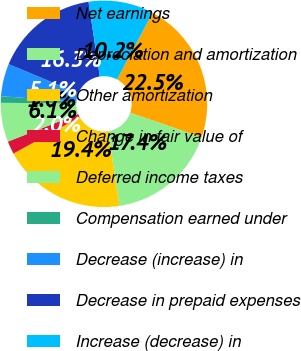Convert chart. <chart><loc_0><loc_0><loc_500><loc_500><pie_chart><fcel>Net earnings<fcel>Depreciation and amortization<fcel>Other amortization<fcel>Change in fair value of<fcel>Deferred income taxes<fcel>Compensation earned under<fcel>Decrease (increase) in<fcel>Decrease in prepaid expenses<fcel>Increase (decrease) in<nl><fcel>22.45%<fcel>17.35%<fcel>19.39%<fcel>2.04%<fcel>6.12%<fcel>1.02%<fcel>5.1%<fcel>16.33%<fcel>10.2%<nl></chart> 